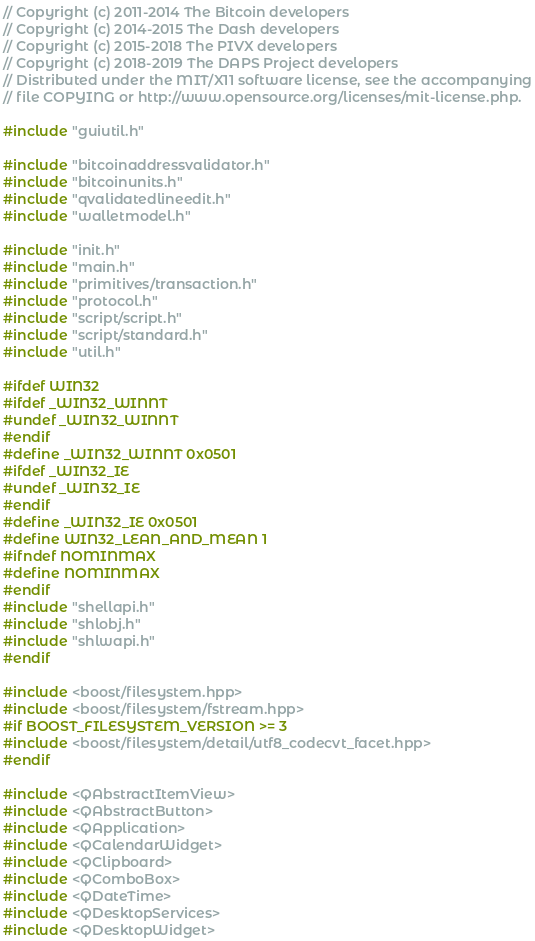<code> <loc_0><loc_0><loc_500><loc_500><_C++_>// Copyright (c) 2011-2014 The Bitcoin developers
// Copyright (c) 2014-2015 The Dash developers
// Copyright (c) 2015-2018 The PIVX developers
// Copyright (c) 2018-2019 The DAPS Project developers
// Distributed under the MIT/X11 software license, see the accompanying
// file COPYING or http://www.opensource.org/licenses/mit-license.php.

#include "guiutil.h"

#include "bitcoinaddressvalidator.h"
#include "bitcoinunits.h"
#include "qvalidatedlineedit.h"
#include "walletmodel.h"

#include "init.h"
#include "main.h"
#include "primitives/transaction.h"
#include "protocol.h"
#include "script/script.h"
#include "script/standard.h"
#include "util.h"

#ifdef WIN32
#ifdef _WIN32_WINNT
#undef _WIN32_WINNT
#endif
#define _WIN32_WINNT 0x0501
#ifdef _WIN32_IE
#undef _WIN32_IE
#endif
#define _WIN32_IE 0x0501
#define WIN32_LEAN_AND_MEAN 1
#ifndef NOMINMAX
#define NOMINMAX
#endif
#include "shellapi.h"
#include "shlobj.h"
#include "shlwapi.h"
#endif

#include <boost/filesystem.hpp>
#include <boost/filesystem/fstream.hpp>
#if BOOST_FILESYSTEM_VERSION >= 3
#include <boost/filesystem/detail/utf8_codecvt_facet.hpp>
#endif

#include <QAbstractItemView>
#include <QAbstractButton>
#include <QApplication>
#include <QCalendarWidget>
#include <QClipboard>
#include <QComboBox>
#include <QDateTime>
#include <QDesktopServices>
#include <QDesktopWidget></code> 